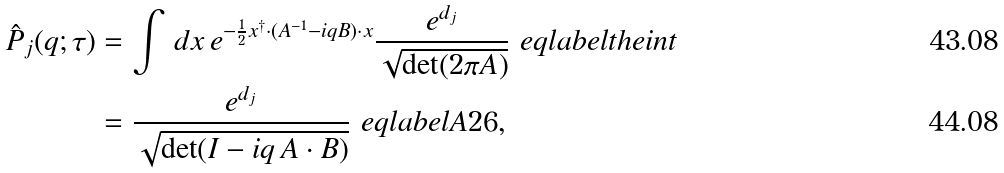Convert formula to latex. <formula><loc_0><loc_0><loc_500><loc_500>\hat { P } _ { j } ( q ; \tau ) & = \int \, d { x } \, e ^ { - \frac { 1 } { 2 } { x } ^ { \dagger } \cdot ( A ^ { - 1 } - i q B ) \cdot { x } } \frac { e ^ { d _ { j } } } { \sqrt { \det ( 2 \pi A ) } } \ e q l a b e l { t h e i n t } \\ & = \frac { e ^ { d _ { j } } } { \sqrt { \det ( I - i q \, A \cdot B ) } } \ e q l a b e l { A 2 6 } ,</formula> 